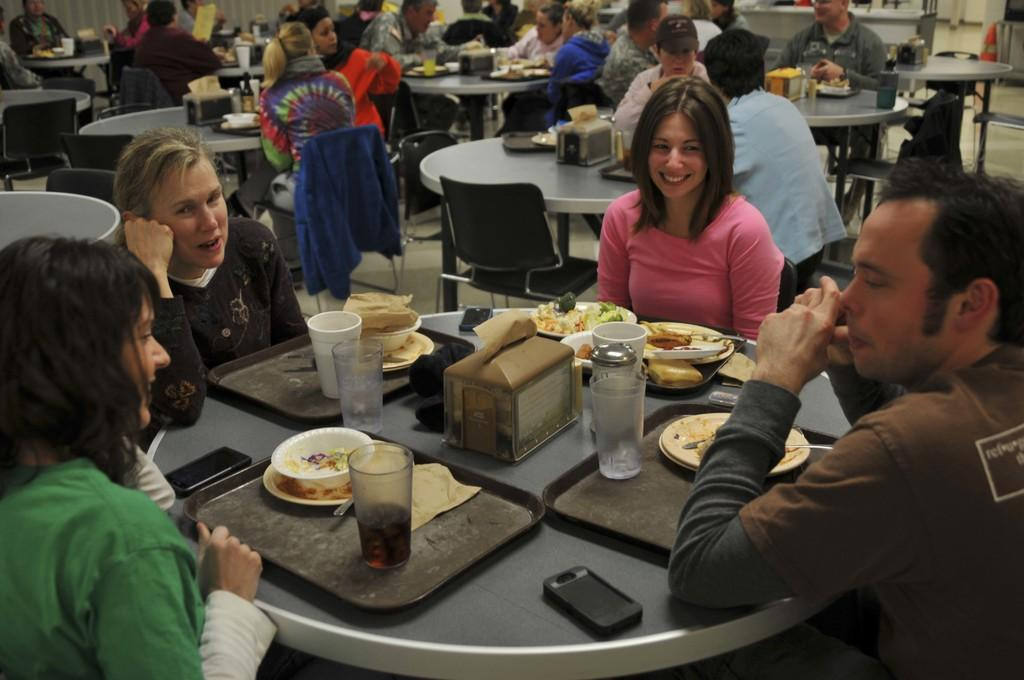What are the people in the image doing? There is a group of people sitting on chairs in the image. What objects can be seen on the table in the image? There is a glass, a bowl, a plate, a spoon, a tissue in a tray, and a mobile phone on the table in the image. What type of yak can be seen grazing in the background of the image? There is no yak present in the image; it features a group of people sitting on chairs and objects on a table. 